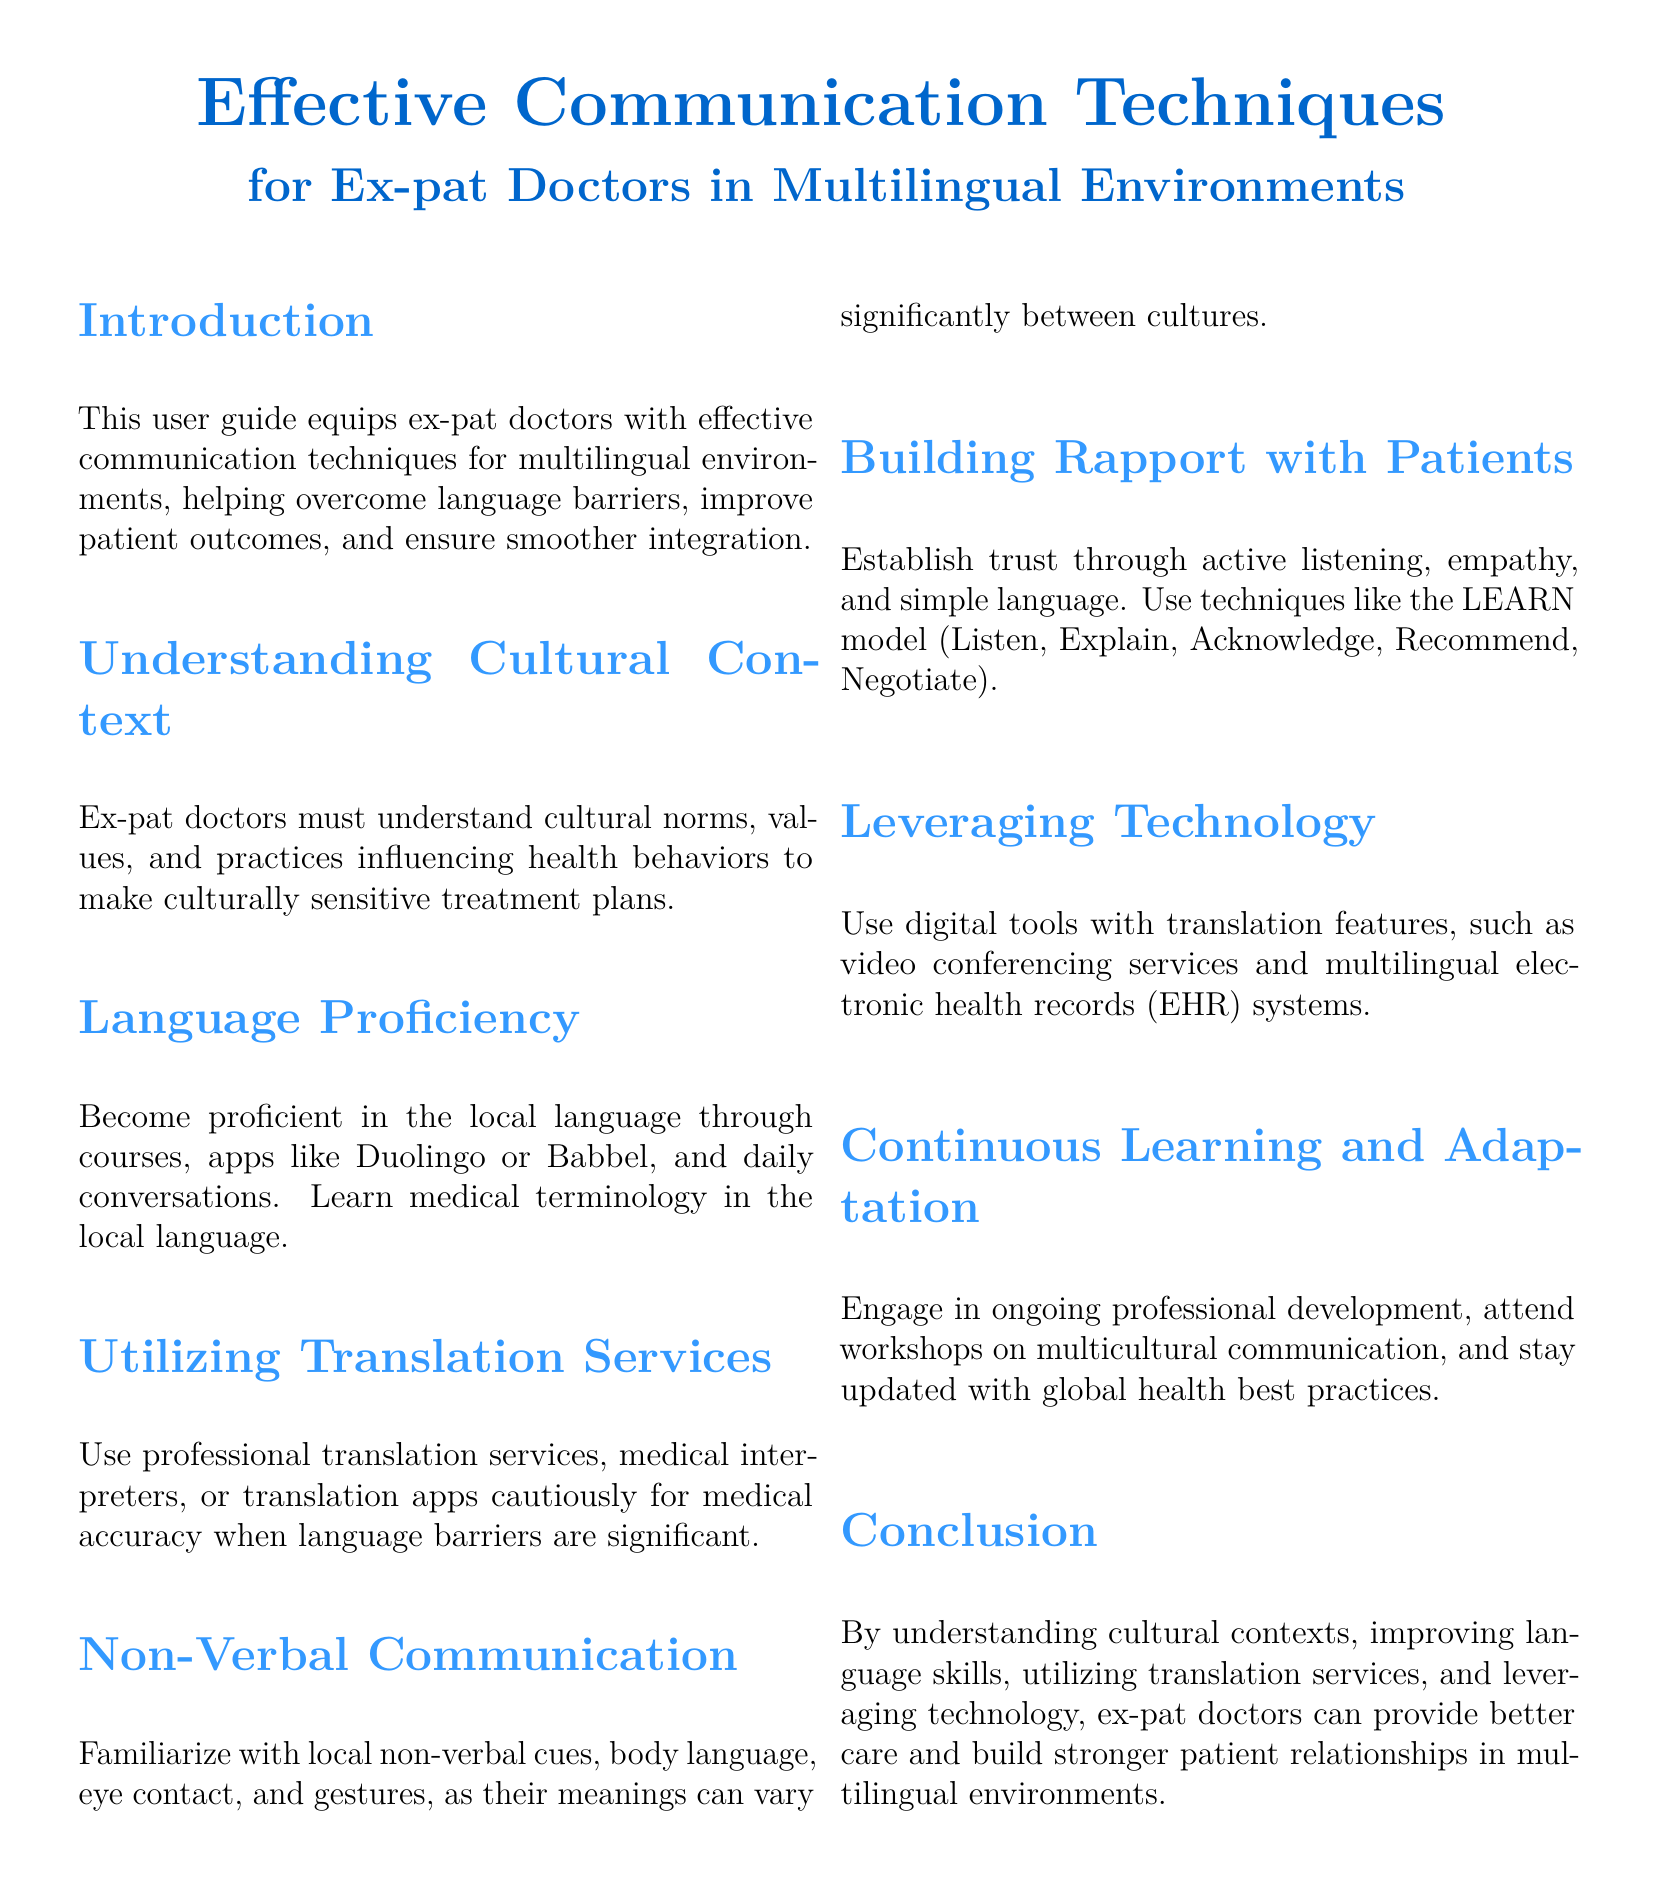What is the title of the document? The title is prominently displayed at the top of the document, which is "Effective Communication Techniques for Ex-pat Doctors in Multilingual Environments."
Answer: Effective Communication Techniques for Ex-pat Doctors in Multilingual Environments What is the main purpose of this user guide? The primary purpose is mentioned in the introduction, which is to equip ex-pat doctors with effective communication techniques.
Answer: To equip ex-pat doctors with effective communication techniques What language learning methods are suggested? The document lists methods such as courses, apps like Duolingo, Babbel, and daily conversations for learning the local language.
Answer: Courses, apps, daily conversations What does the LEARN model stand for? The LEARN model includes steps mentioned in the document: Listen, Explain, Acknowledge, Recommend, Negotiate.
Answer: Listen, Explain, Acknowledge, Recommend, Negotiate Which type of services should ex-pat doctors use for language barriers? The document advises using professional translation services, medical interpreters, or translation apps.
Answer: Professional translation services How can ex-pat doctors establish trust with patients? It is explained that trust can be established through active listening, empathy, and simple language.
Answer: Active listening, empathy, simple language What is emphasized as an important skill in multilingual environments? The document emphasizes the need for understanding cultural norms, values, and practices.
Answer: Understanding cultural norms What is one way to leverage technology effectively? The document mentions using digital tools with translation features as an effective strategy.
Answer: Digital tools with translation features How should ex-pat doctors approach continuous learning? Continuous learning is recommended through ongoing professional development and attending workshops.
Answer: Ongoing professional development What role does non-verbal communication play according to the guide? The guide states that non-verbal communication and gestures can have varying meanings between cultures.
Answer: It varies between cultures 